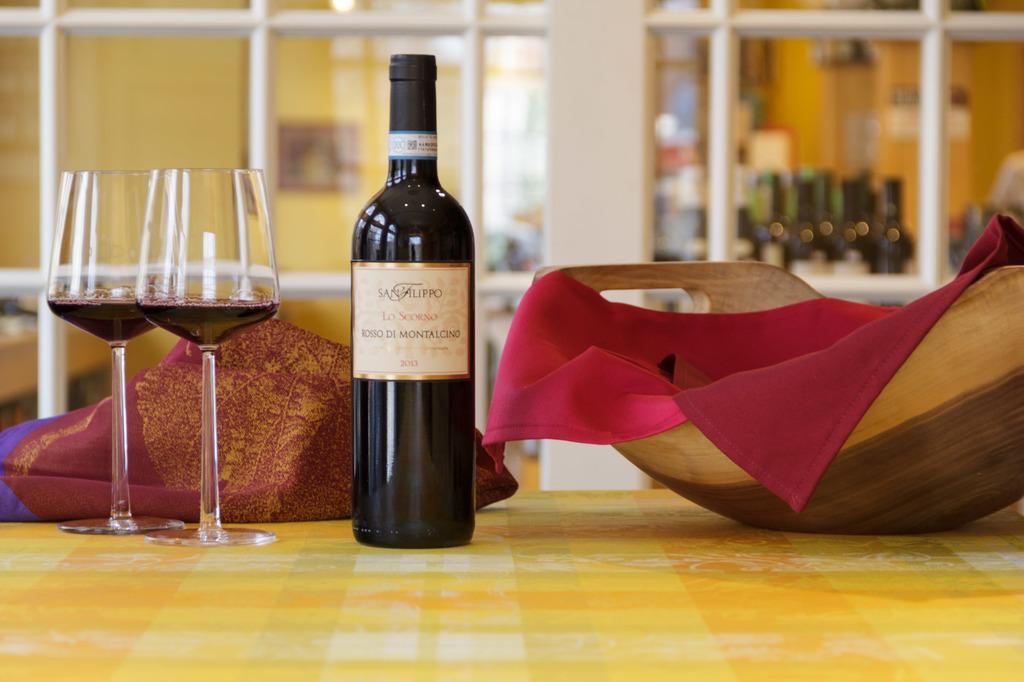What piece of furniture is present in the image? There is a table in the image. What is placed on the table? There is a bottle and two wine glasses on the table. What type of container is visible in the image? There is a wooden basket in the image. What can be seen in the background of the image? There is a wall in the background of the image, and frames are on the wall. How does the fork fall from the table in the image? There is no fork present in the image, so it cannot fall from the table. 